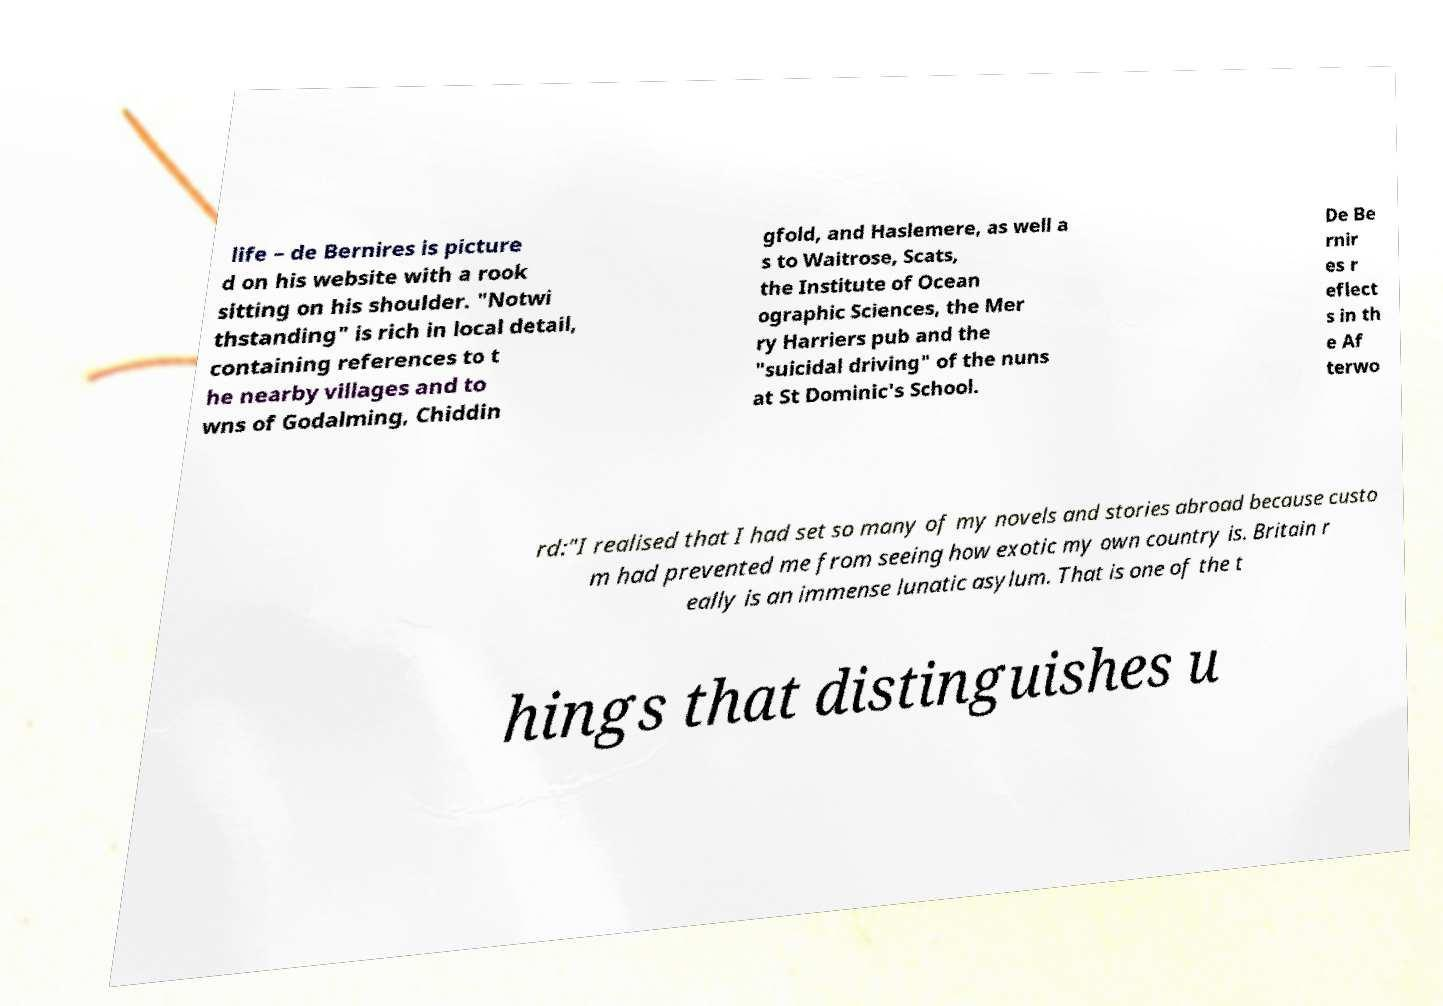For documentation purposes, I need the text within this image transcribed. Could you provide that? life – de Bernires is picture d on his website with a rook sitting on his shoulder. "Notwi thstanding" is rich in local detail, containing references to t he nearby villages and to wns of Godalming, Chiddin gfold, and Haslemere, as well a s to Waitrose, Scats, the Institute of Ocean ographic Sciences, the Mer ry Harriers pub and the "suicidal driving" of the nuns at St Dominic's School. De Be rnir es r eflect s in th e Af terwo rd:"I realised that I had set so many of my novels and stories abroad because custo m had prevented me from seeing how exotic my own country is. Britain r eally is an immense lunatic asylum. That is one of the t hings that distinguishes u 